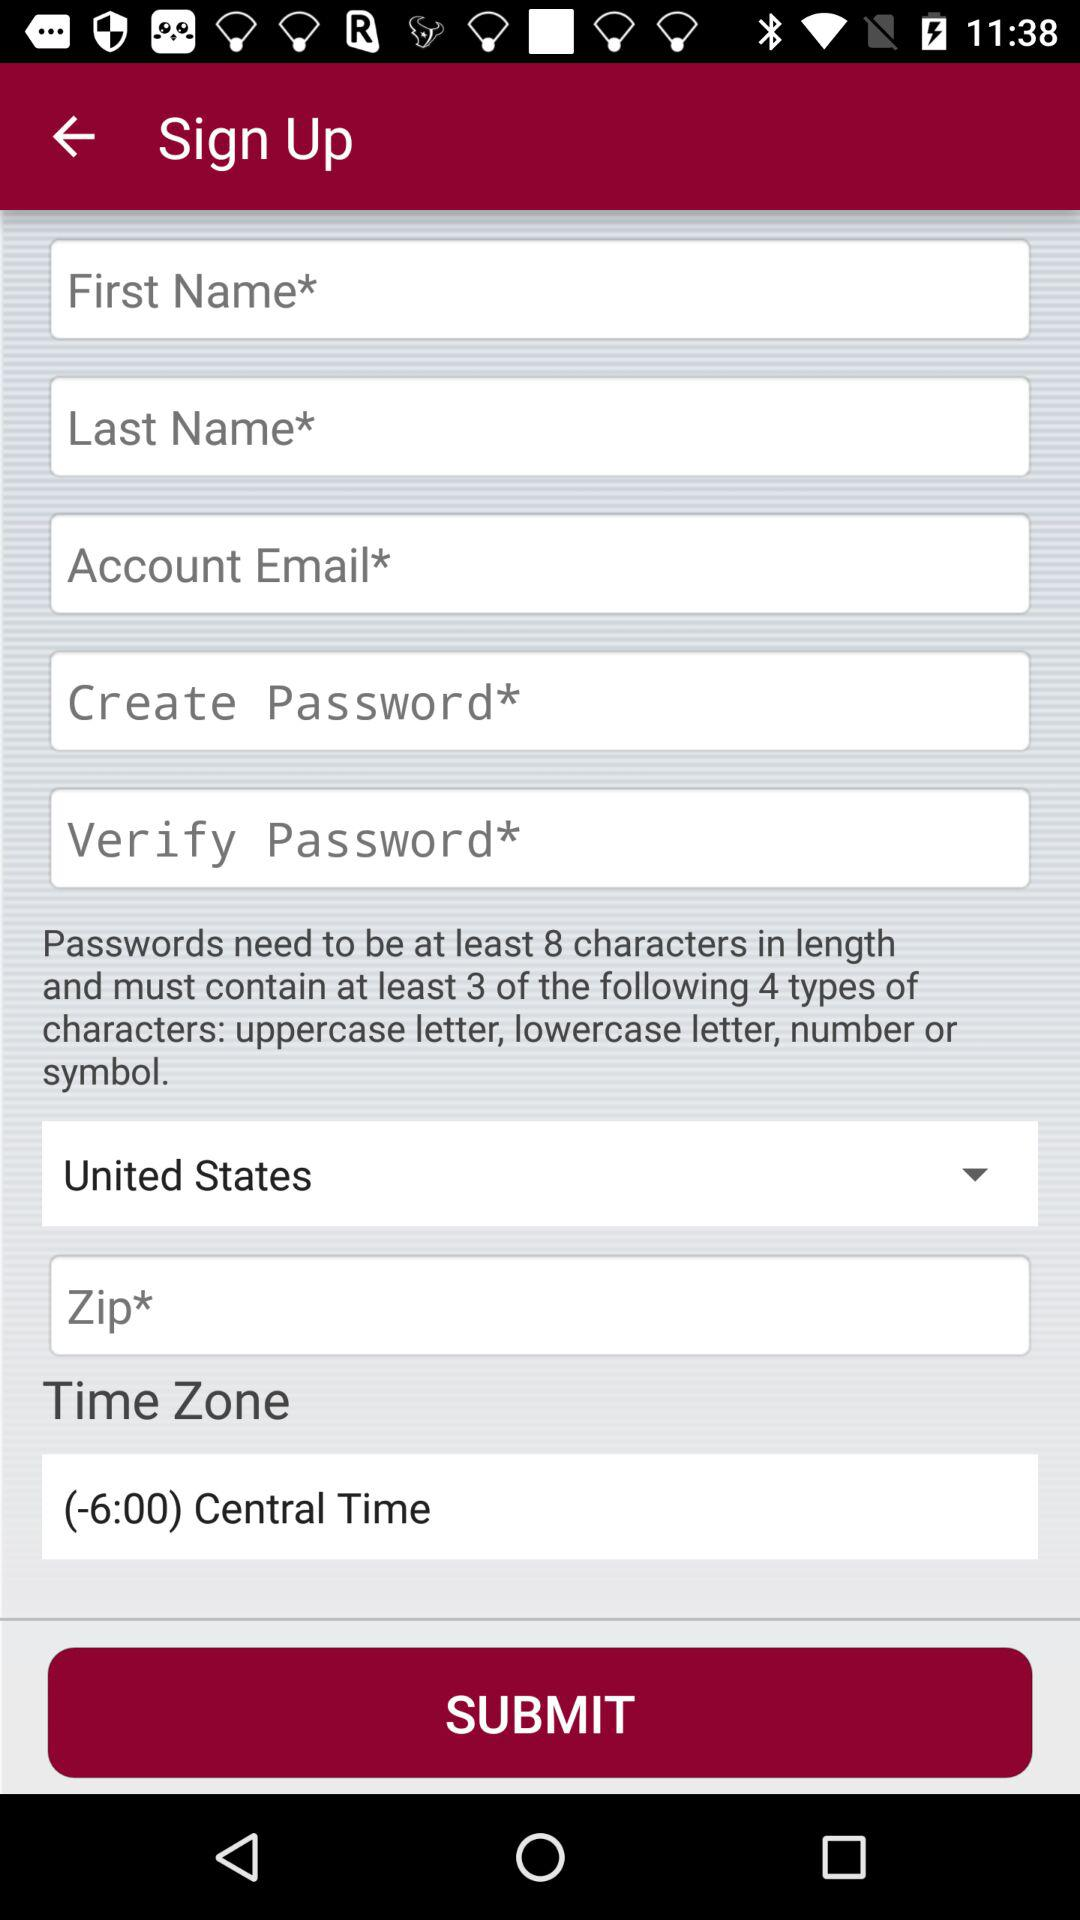Which country is selected? The selected country is the United States. 